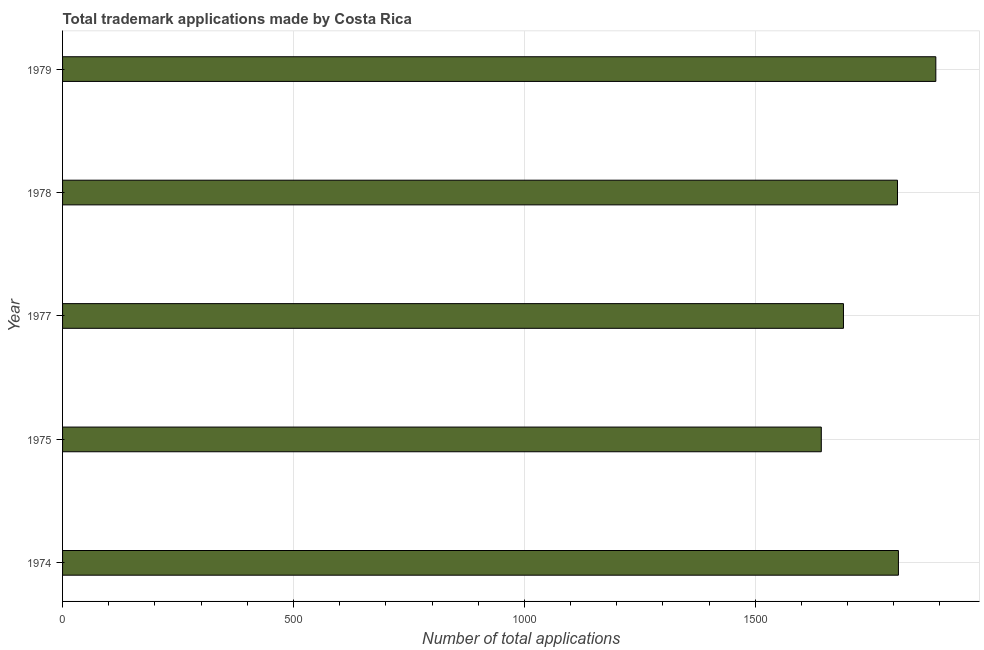Does the graph contain any zero values?
Provide a succinct answer. No. What is the title of the graph?
Keep it short and to the point. Total trademark applications made by Costa Rica. What is the label or title of the X-axis?
Your response must be concise. Number of total applications. What is the number of trademark applications in 1977?
Your answer should be very brief. 1691. Across all years, what is the maximum number of trademark applications?
Ensure brevity in your answer.  1891. Across all years, what is the minimum number of trademark applications?
Offer a very short reply. 1643. In which year was the number of trademark applications maximum?
Your answer should be very brief. 1979. In which year was the number of trademark applications minimum?
Make the answer very short. 1975. What is the sum of the number of trademark applications?
Provide a succinct answer. 8843. What is the difference between the number of trademark applications in 1975 and 1977?
Ensure brevity in your answer.  -48. What is the average number of trademark applications per year?
Keep it short and to the point. 1768. What is the median number of trademark applications?
Your response must be concise. 1808. Do a majority of the years between 1975 and 1974 (inclusive) have number of trademark applications greater than 700 ?
Ensure brevity in your answer.  No. What is the ratio of the number of trademark applications in 1975 to that in 1979?
Provide a succinct answer. 0.87. Is the number of trademark applications in 1974 less than that in 1978?
Provide a short and direct response. No. What is the difference between the highest and the second highest number of trademark applications?
Your answer should be compact. 81. What is the difference between the highest and the lowest number of trademark applications?
Offer a very short reply. 248. In how many years, is the number of trademark applications greater than the average number of trademark applications taken over all years?
Provide a succinct answer. 3. Are all the bars in the graph horizontal?
Offer a very short reply. Yes. What is the difference between two consecutive major ticks on the X-axis?
Offer a very short reply. 500. Are the values on the major ticks of X-axis written in scientific E-notation?
Your response must be concise. No. What is the Number of total applications of 1974?
Provide a short and direct response. 1810. What is the Number of total applications in 1975?
Provide a succinct answer. 1643. What is the Number of total applications of 1977?
Offer a very short reply. 1691. What is the Number of total applications in 1978?
Provide a succinct answer. 1808. What is the Number of total applications of 1979?
Offer a very short reply. 1891. What is the difference between the Number of total applications in 1974 and 1975?
Make the answer very short. 167. What is the difference between the Number of total applications in 1974 and 1977?
Keep it short and to the point. 119. What is the difference between the Number of total applications in 1974 and 1978?
Give a very brief answer. 2. What is the difference between the Number of total applications in 1974 and 1979?
Offer a terse response. -81. What is the difference between the Number of total applications in 1975 and 1977?
Offer a very short reply. -48. What is the difference between the Number of total applications in 1975 and 1978?
Offer a terse response. -165. What is the difference between the Number of total applications in 1975 and 1979?
Keep it short and to the point. -248. What is the difference between the Number of total applications in 1977 and 1978?
Keep it short and to the point. -117. What is the difference between the Number of total applications in 1977 and 1979?
Ensure brevity in your answer.  -200. What is the difference between the Number of total applications in 1978 and 1979?
Make the answer very short. -83. What is the ratio of the Number of total applications in 1974 to that in 1975?
Provide a short and direct response. 1.1. What is the ratio of the Number of total applications in 1974 to that in 1977?
Provide a short and direct response. 1.07. What is the ratio of the Number of total applications in 1974 to that in 1979?
Your answer should be very brief. 0.96. What is the ratio of the Number of total applications in 1975 to that in 1977?
Make the answer very short. 0.97. What is the ratio of the Number of total applications in 1975 to that in 1978?
Provide a succinct answer. 0.91. What is the ratio of the Number of total applications in 1975 to that in 1979?
Offer a terse response. 0.87. What is the ratio of the Number of total applications in 1977 to that in 1978?
Offer a very short reply. 0.94. What is the ratio of the Number of total applications in 1977 to that in 1979?
Your answer should be compact. 0.89. What is the ratio of the Number of total applications in 1978 to that in 1979?
Give a very brief answer. 0.96. 